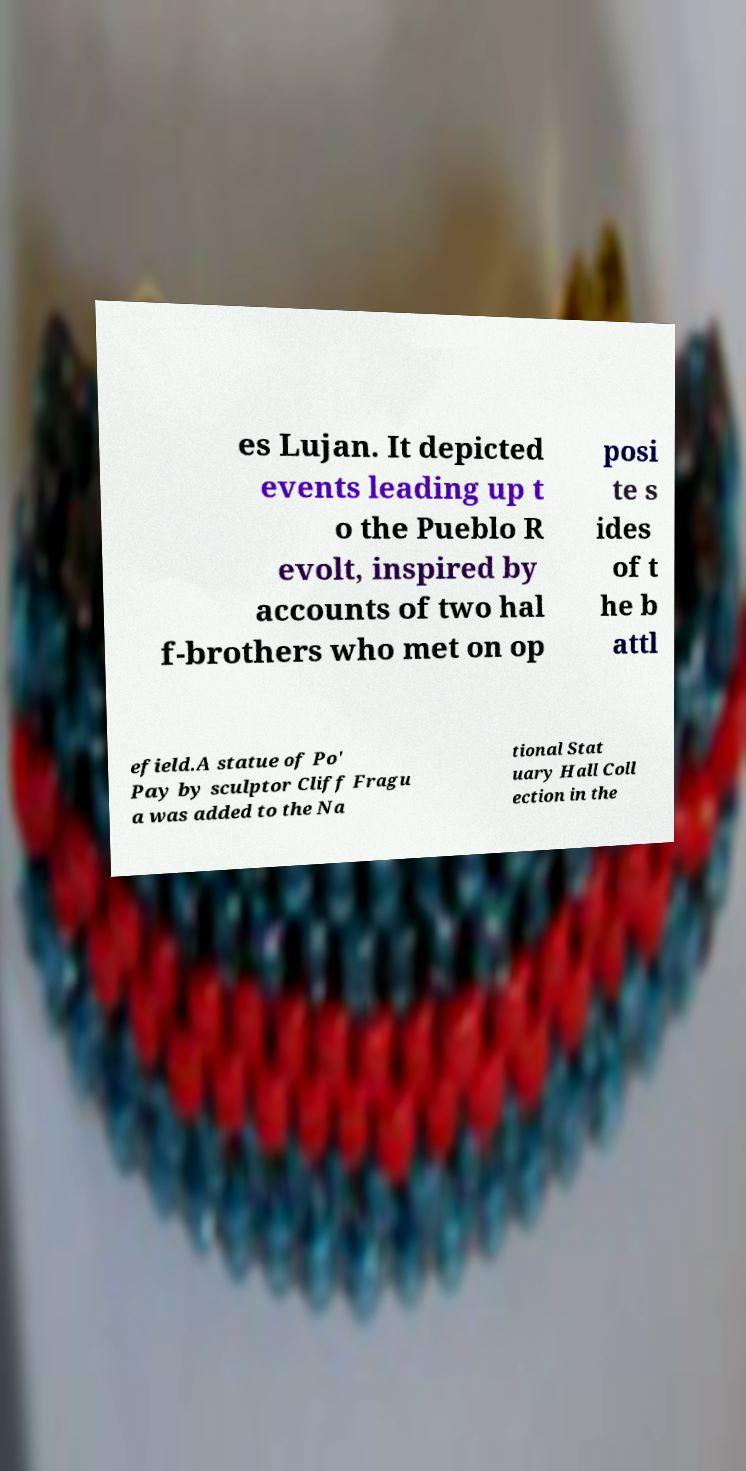Could you extract and type out the text from this image? es Lujan. It depicted events leading up t o the Pueblo R evolt, inspired by accounts of two hal f-brothers who met on op posi te s ides of t he b attl efield.A statue of Po' Pay by sculptor Cliff Fragu a was added to the Na tional Stat uary Hall Coll ection in the 